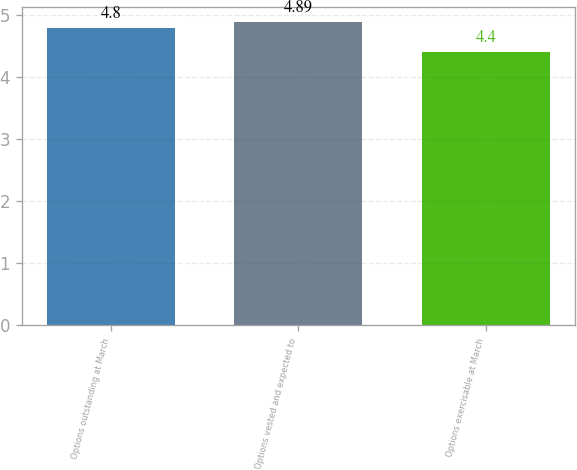Convert chart. <chart><loc_0><loc_0><loc_500><loc_500><bar_chart><fcel>Options outstanding at March<fcel>Options vested and expected to<fcel>Options exercisable at March<nl><fcel>4.8<fcel>4.89<fcel>4.4<nl></chart> 